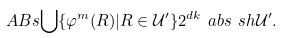Convert formula to latex. <formula><loc_0><loc_0><loc_500><loc_500>\ A B s { \bigcup \{ \varphi ^ { m } ( R ) | R \in \mathcal { U } ^ { \prime } \} } 2 ^ { d k } \ a b s { \ s h { \mathcal { U } ^ { \prime } } } .</formula> 